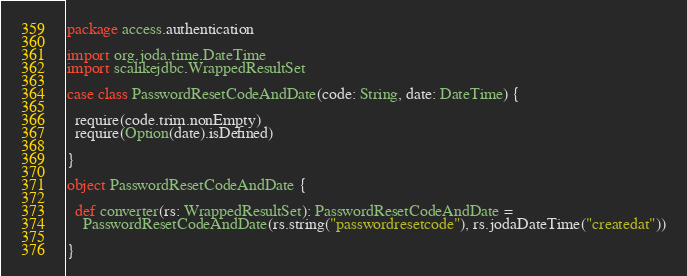Convert code to text. <code><loc_0><loc_0><loc_500><loc_500><_Scala_>package access.authentication

import org.joda.time.DateTime
import scalikejdbc.WrappedResultSet

case class PasswordResetCodeAndDate(code: String, date: DateTime) {

  require(code.trim.nonEmpty)
  require(Option(date).isDefined)

}

object PasswordResetCodeAndDate {

  def converter(rs: WrappedResultSet): PasswordResetCodeAndDate =
    PasswordResetCodeAndDate(rs.string("passwordresetcode"), rs.jodaDateTime("createdat"))

}</code> 